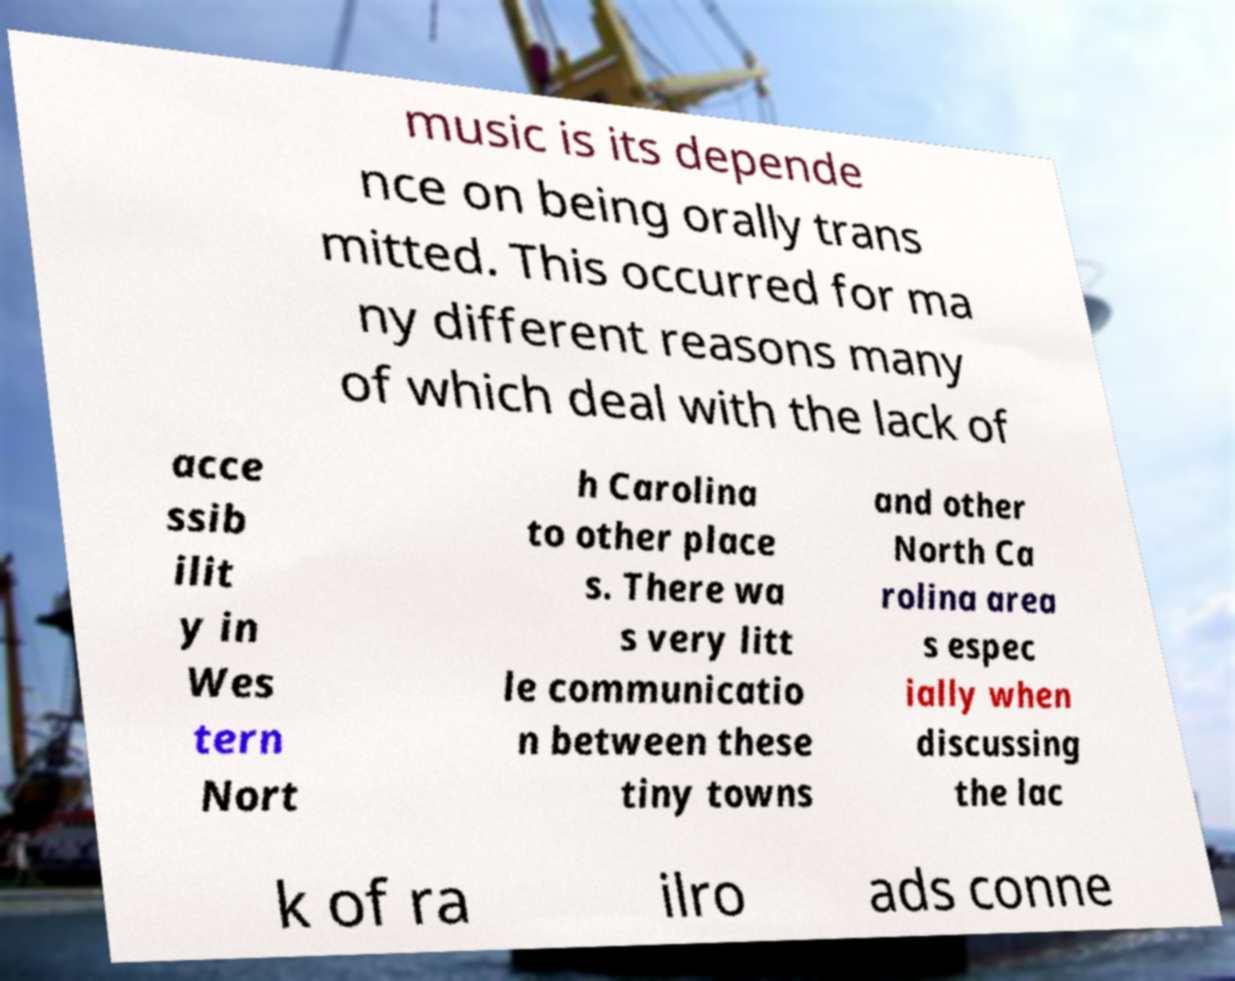Can you accurately transcribe the text from the provided image for me? music is its depende nce on being orally trans mitted. This occurred for ma ny different reasons many of which deal with the lack of acce ssib ilit y in Wes tern Nort h Carolina to other place s. There wa s very litt le communicatio n between these tiny towns and other North Ca rolina area s espec ially when discussing the lac k of ra ilro ads conne 